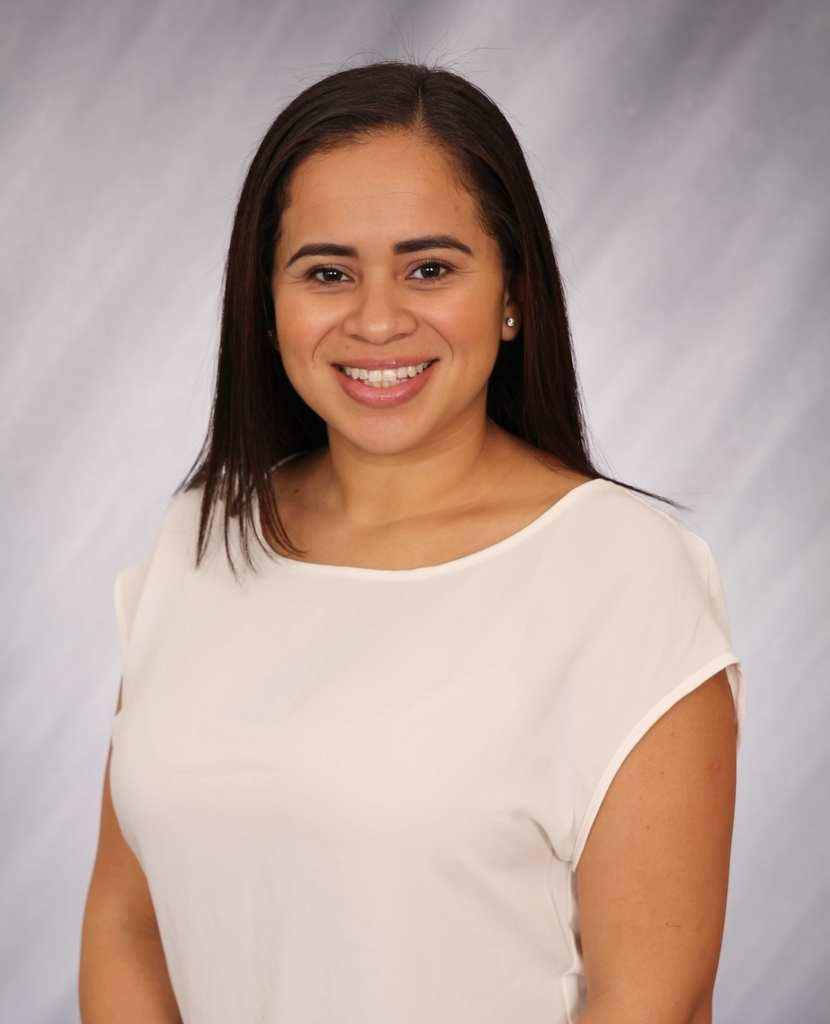Who is the main subject in the image? There is a woman in the image. What is the woman wearing? The woman is wearing a white t-shirt. What is the woman's facial expression? The woman is smiling. What is the woman's posture in the image? The woman is standing. Can you describe the background of the image? The background of the image is blurred. Where is the woman eating her lunch in the image? There is no mention of lunch or a specific location in the image, so we cannot determine where the woman is eating. 